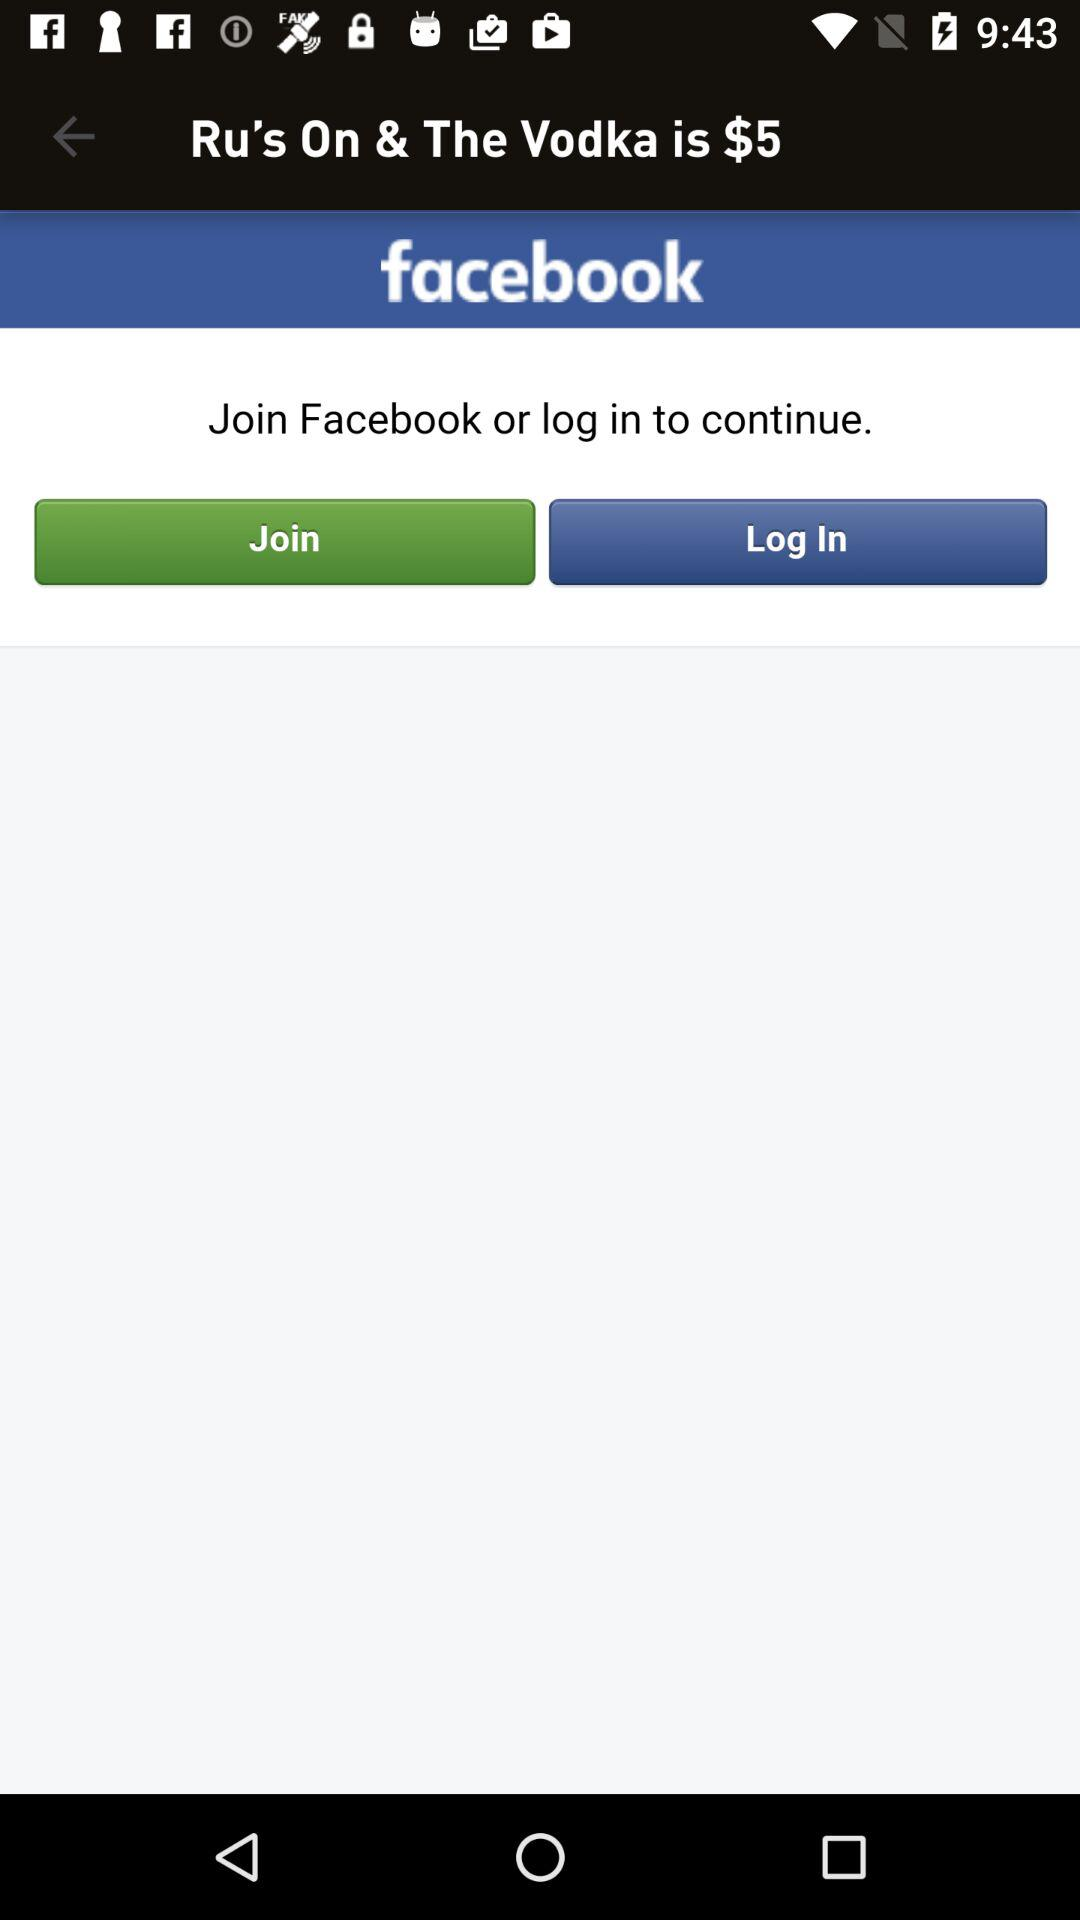What other applications can be used to log in to the profile? You can login with Facebook. 